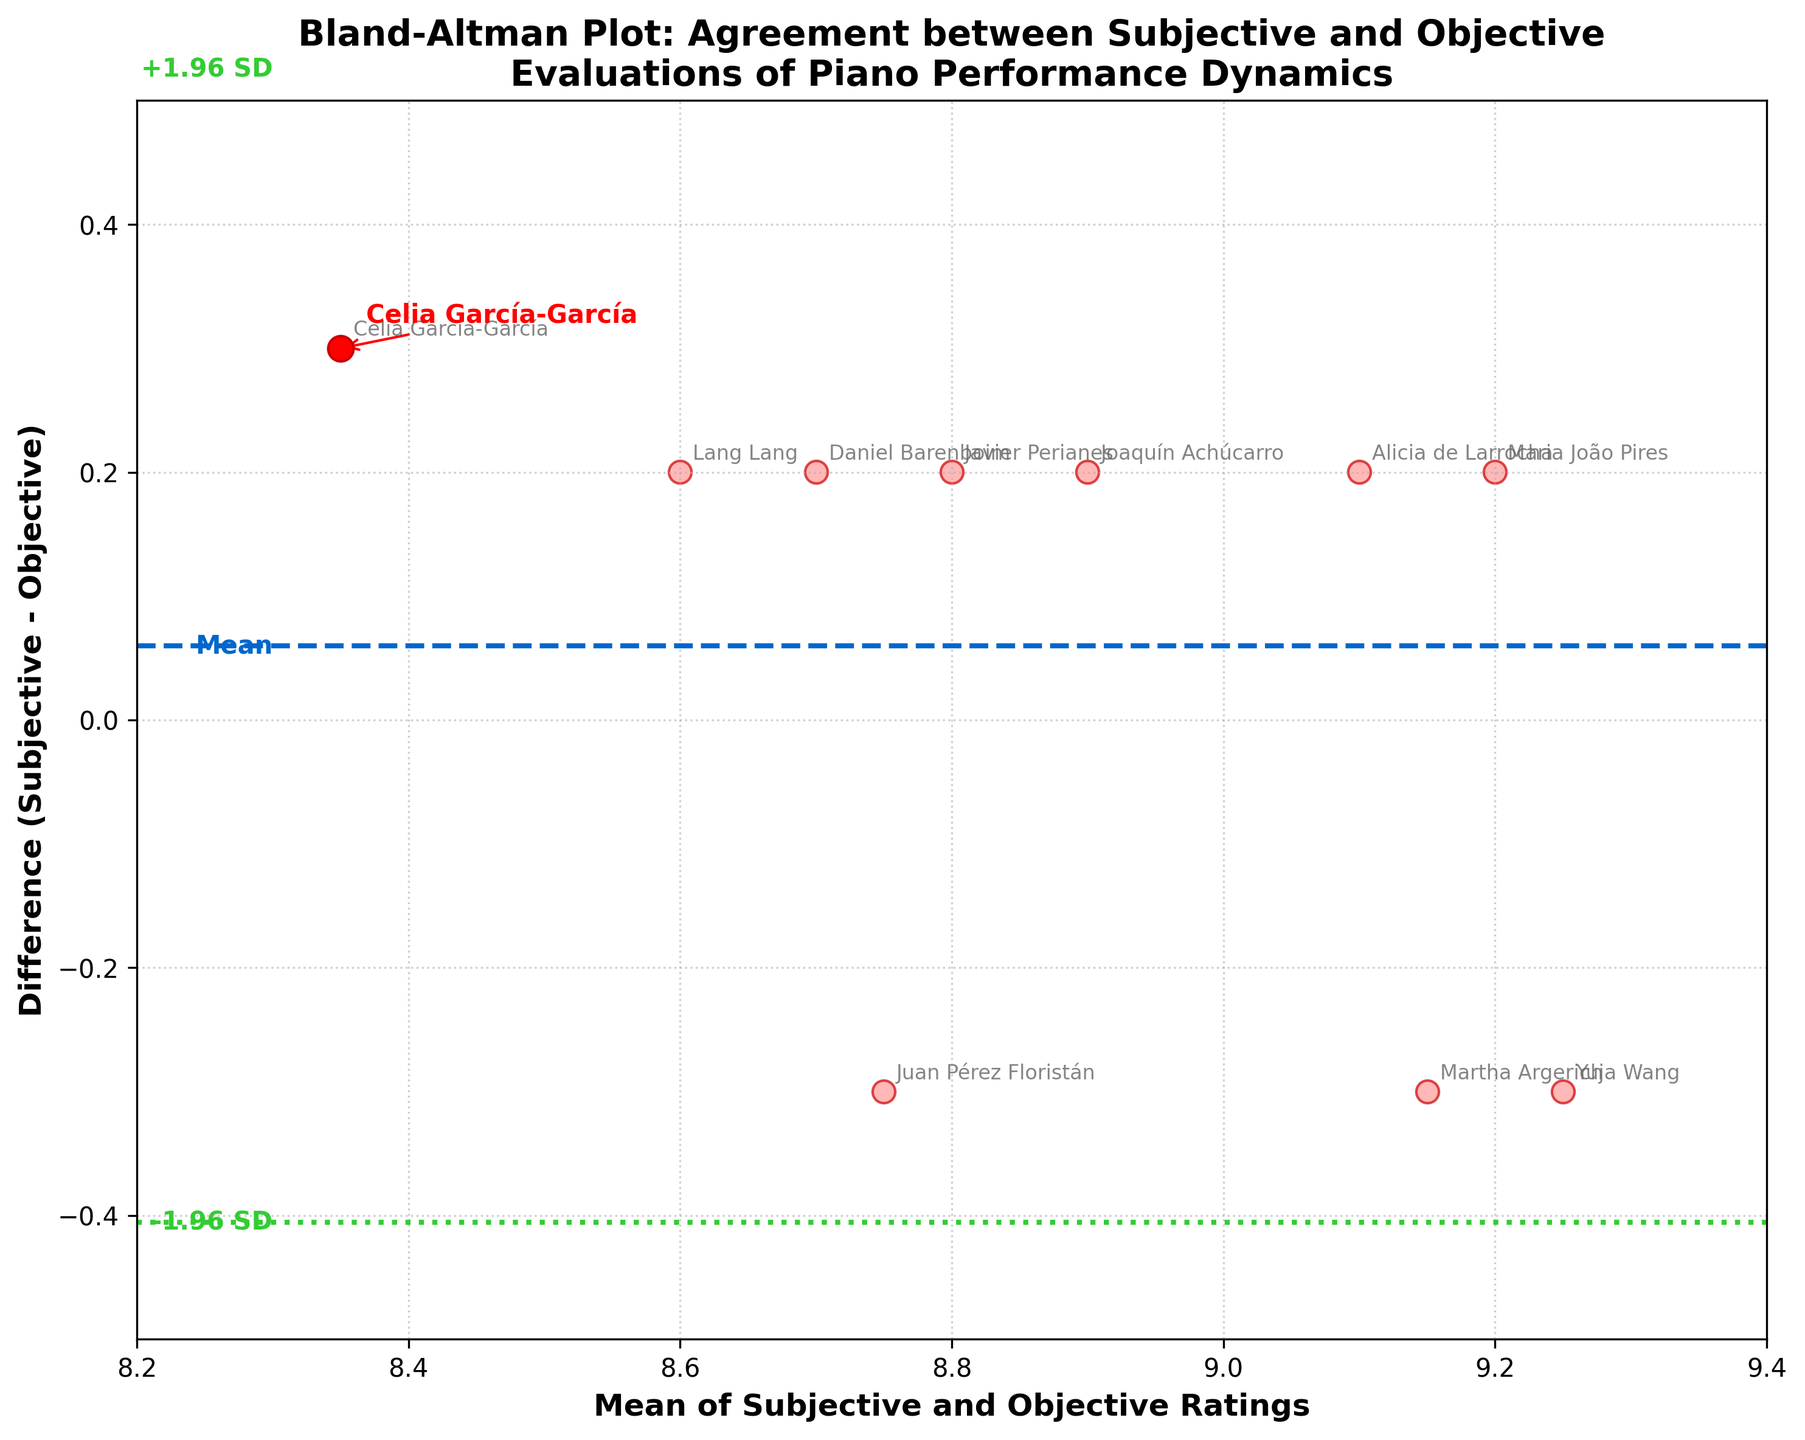What is the title of the figure? The title is written at the top of the figure and describes what the figure represents.
Answer: Bland-Altman Plot: Agreement between Subjective and Objective Evaluations of Piano Performance Dynamics Who has the highest subjective rating? The subjective ratings' values are represented and labeled for each performer. Looking at the data points or annotations, the highest subjective rating is 9.3, given to Maria João Pires.
Answer: Maria João Pires How many performers have a positive difference between subjective and objective ratings? By examining the difference values plotted, we count the number of points where the difference is above the horizontal line representing zero.
Answer: 6 What are the limits of agreement in this plot? The limits of agreement are represented by the horizontal dashed lines at +1.96 SD and -1.96 SD from the mean difference.
Answer: +1.96 SD and -1.96 SD For which performer is the subjective rating exactly 0.3 higher than the objective rating? Looking at the annotations and the differences given next to the data points, we find the performer whose difference is 0.3.
Answer: Celia García-García Is the mean difference positive or negative? The mean difference is represented by the central dashed line's value. Checking its position relative to zero on the difference axis helps determine its sign.
Answer: Positive What is the mean rating for Lang Lang? The mean of Lang Lang's subjective and objective ratings is given next to his data point on the plot.
Answer: 8.6 What is the difference between the subjective and objective ratings for Juan Pérez Floristán? Next to Juan Pérez Floristán's data point, the difference value is annotated.
Answer: -0.3 How many performers are rated by subjective measures higher than 9? By counting the performers whose subjective ratings are above 9 in either the annotations or the data points, we can find the answer.
Answer: 4 Describe how Celia García-García's data point is highlighted. The plot contains a specific annotation or visual distinctiveness for Celia García-García compared to other data points, such as color or size, meant to catch the viewer's eye.
Answer: Highlighted with a red color and an arrow 